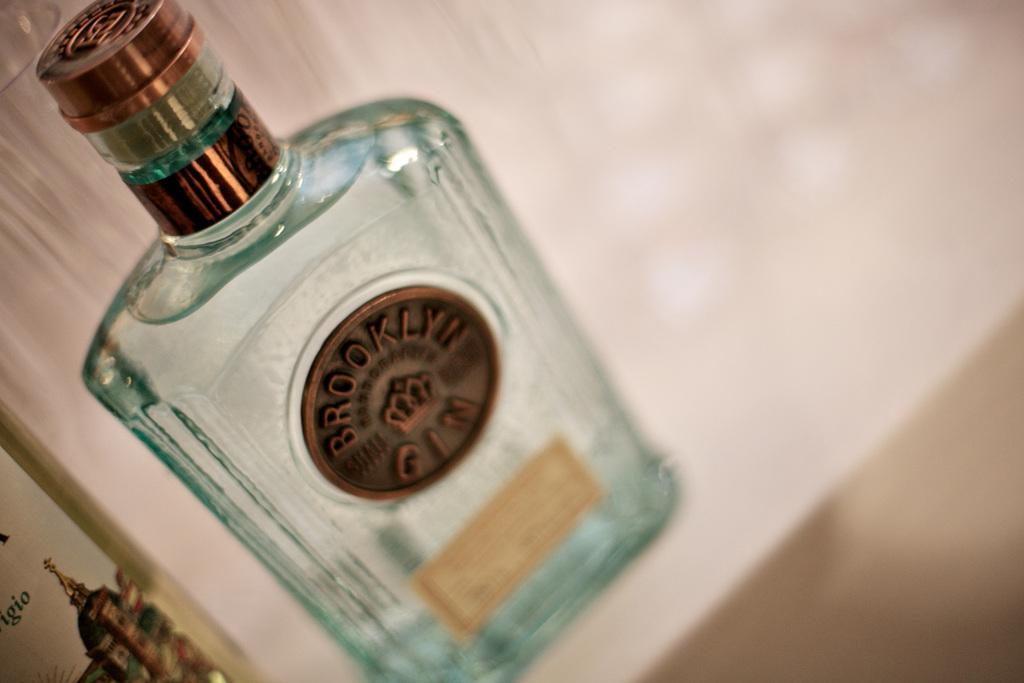What object can be seen in the image? There is a bottle in the image. What feature is present on the bottle? The bottle has a logo on it. What word is included in the logo? The logo contains the word "BROOKLYN." What type of twig is used to create the logo on the bottle? There is no twig used to create the logo on the bottle; it is a printed logo. What material is the silk used for the logo on the bottle? There is no silk used for the logo on the bottle; it is a printed logo. 